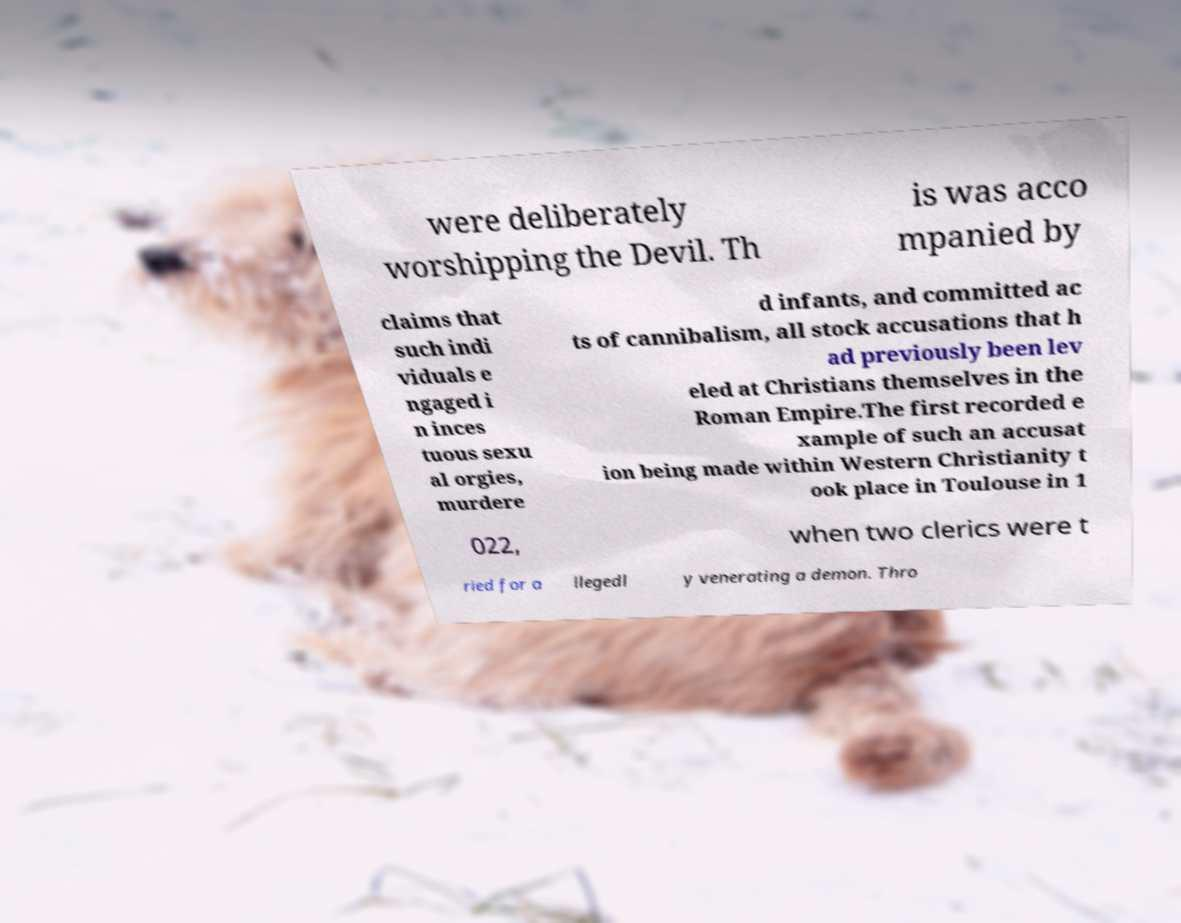Please identify and transcribe the text found in this image. were deliberately worshipping the Devil. Th is was acco mpanied by claims that such indi viduals e ngaged i n inces tuous sexu al orgies, murdere d infants, and committed ac ts of cannibalism, all stock accusations that h ad previously been lev eled at Christians themselves in the Roman Empire.The first recorded e xample of such an accusat ion being made within Western Christianity t ook place in Toulouse in 1 022, when two clerics were t ried for a llegedl y venerating a demon. Thro 